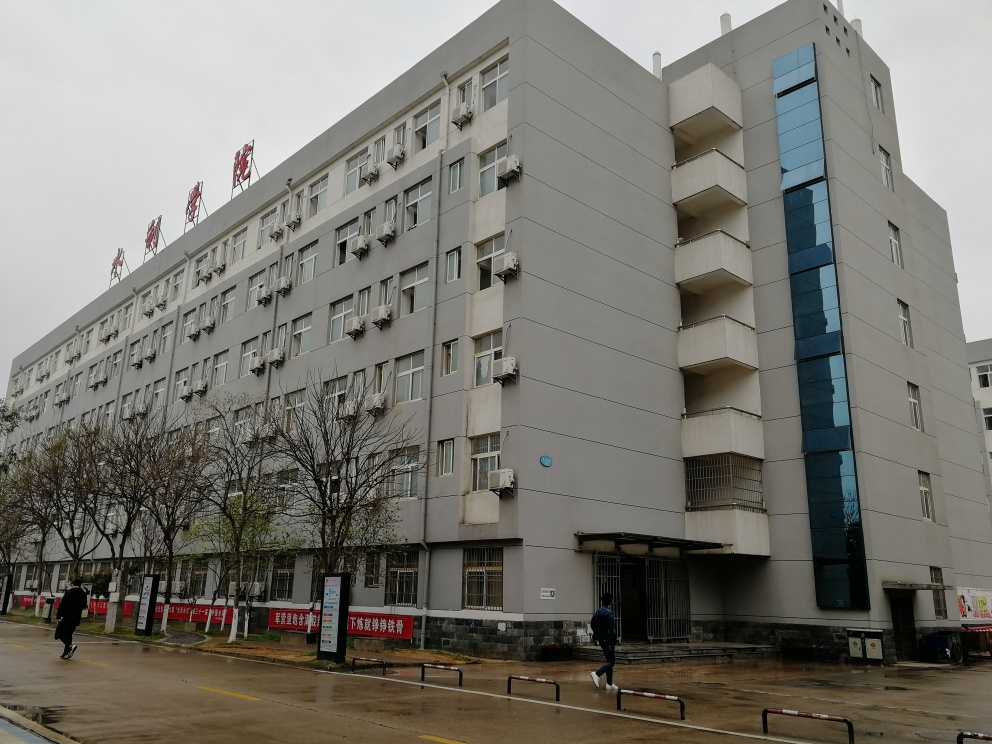Is there any signage or writing that indicates what the building is used for? There are several signs on the building and the fence in front. Although the text is not fully legible from the image provided, the presence of these signs suggests that the building likely serves a specific institutional purpose or is an office/apartment complex. Could you guess what type of institution it might be? Given the standardized appearance of the building and what appears to be multiple air conditioning units on the facade, it could be a commercial building, potentially housing offices or serving as governmental or educational facilities. However, without clearer text or more context, it's difficult to determine the exact use with certainty. 